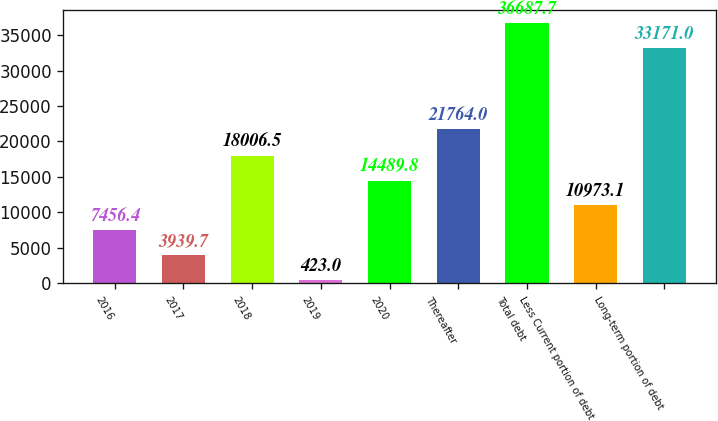Convert chart. <chart><loc_0><loc_0><loc_500><loc_500><bar_chart><fcel>2016<fcel>2017<fcel>2018<fcel>2019<fcel>2020<fcel>Thereafter<fcel>Total debt<fcel>Less Current portion of debt<fcel>Long-term portion of debt<nl><fcel>7456.4<fcel>3939.7<fcel>18006.5<fcel>423<fcel>14489.8<fcel>21764<fcel>36687.7<fcel>10973.1<fcel>33171<nl></chart> 